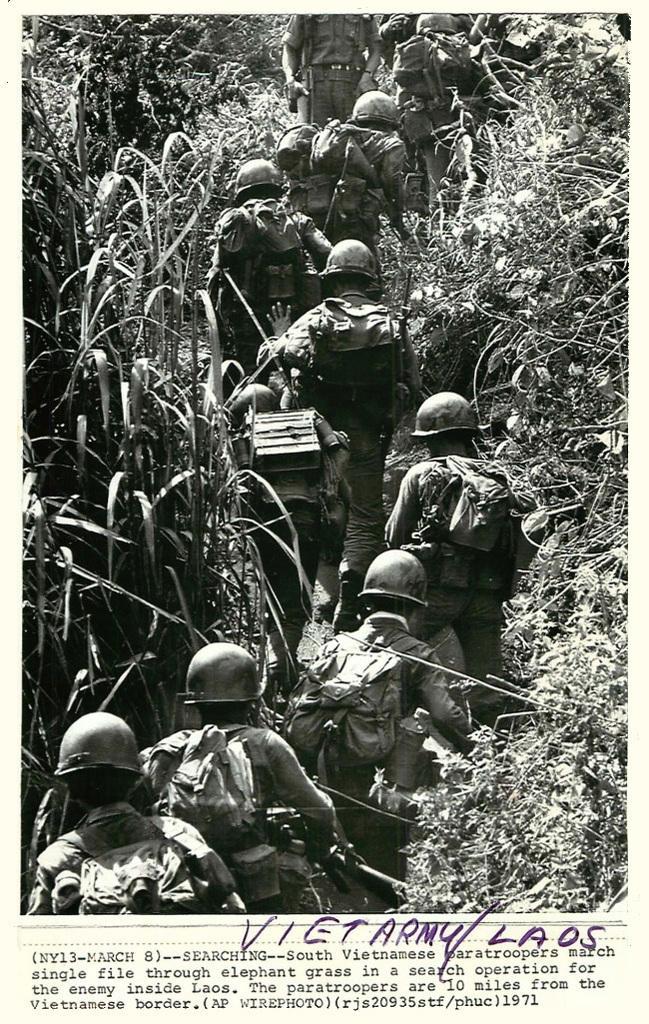Describe this image in one or two sentences. This is a black and white image. In this image we can see many people wearing helmets and bags. On the sides there are plants. At the bottom there is text. 